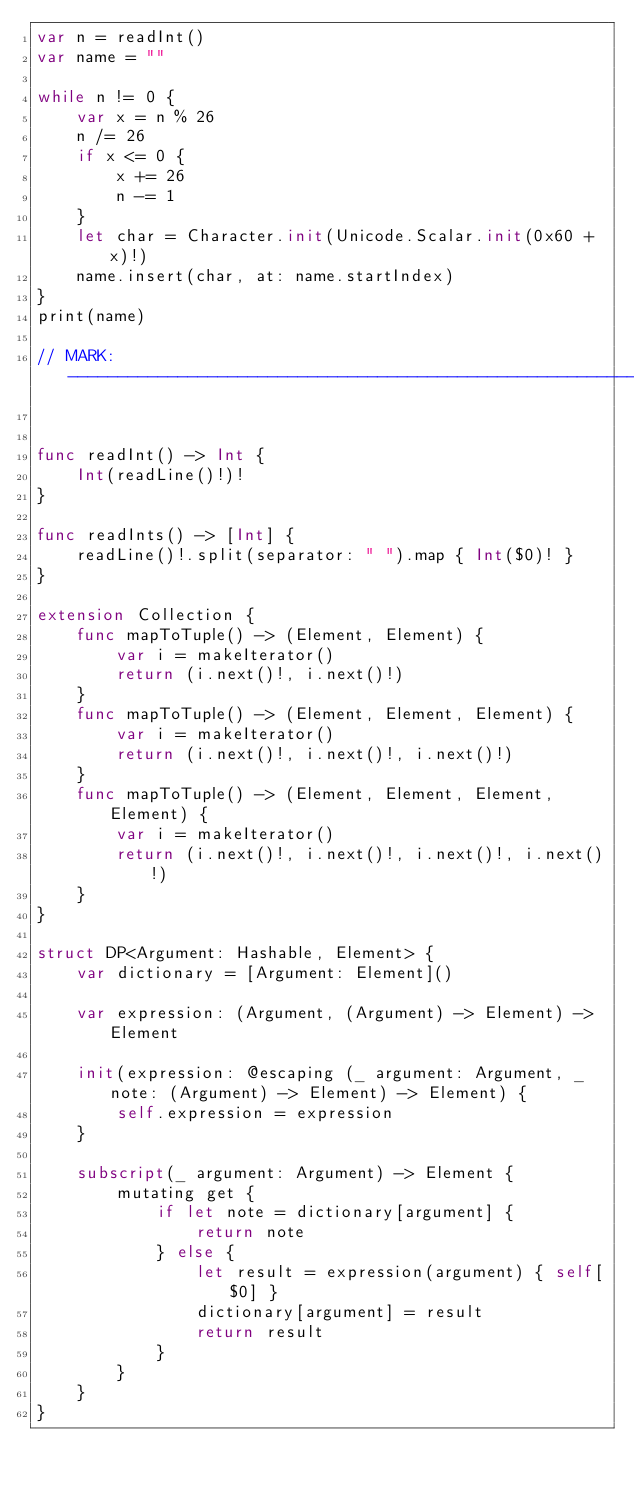<code> <loc_0><loc_0><loc_500><loc_500><_Swift_>var n = readInt()
var name = ""

while n != 0 {
    var x = n % 26
    n /= 26
    if x <= 0 {
        x += 26
        n -= 1
    }
    let char = Character.init(Unicode.Scalar.init(0x60 + x)!)
    name.insert(char, at: name.startIndex)
}
print(name)

// MARK: -----------------------------------------------------------------------


func readInt() -> Int {
    Int(readLine()!)!
}

func readInts() -> [Int] {
    readLine()!.split(separator: " ").map { Int($0)! }
}

extension Collection {
    func mapToTuple() -> (Element, Element) {
        var i = makeIterator()
        return (i.next()!, i.next()!)
    }
    func mapToTuple() -> (Element, Element, Element) {
        var i = makeIterator()
        return (i.next()!, i.next()!, i.next()!)
    }
    func mapToTuple() -> (Element, Element, Element, Element) {
        var i = makeIterator()
        return (i.next()!, i.next()!, i.next()!, i.next()!)
    }
}

struct DP<Argument: Hashable, Element> {
    var dictionary = [Argument: Element]()
    
    var expression: (Argument, (Argument) -> Element) -> Element
    
    init(expression: @escaping (_ argument: Argument, _ note: (Argument) -> Element) -> Element) {
        self.expression = expression
    }
    
    subscript(_ argument: Argument) -> Element {
        mutating get {
            if let note = dictionary[argument] {
                return note
            } else {
                let result = expression(argument) { self[$0] }
                dictionary[argument] = result
                return result
            }
        }
    }
}
</code> 